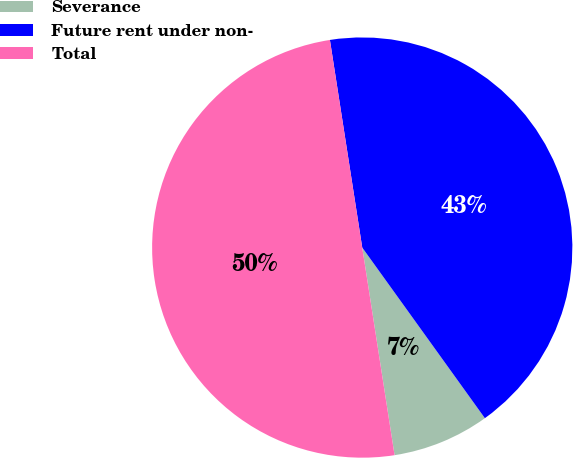<chart> <loc_0><loc_0><loc_500><loc_500><pie_chart><fcel>Severance<fcel>Future rent under non-<fcel>Total<nl><fcel>7.46%<fcel>42.54%<fcel>50.0%<nl></chart> 